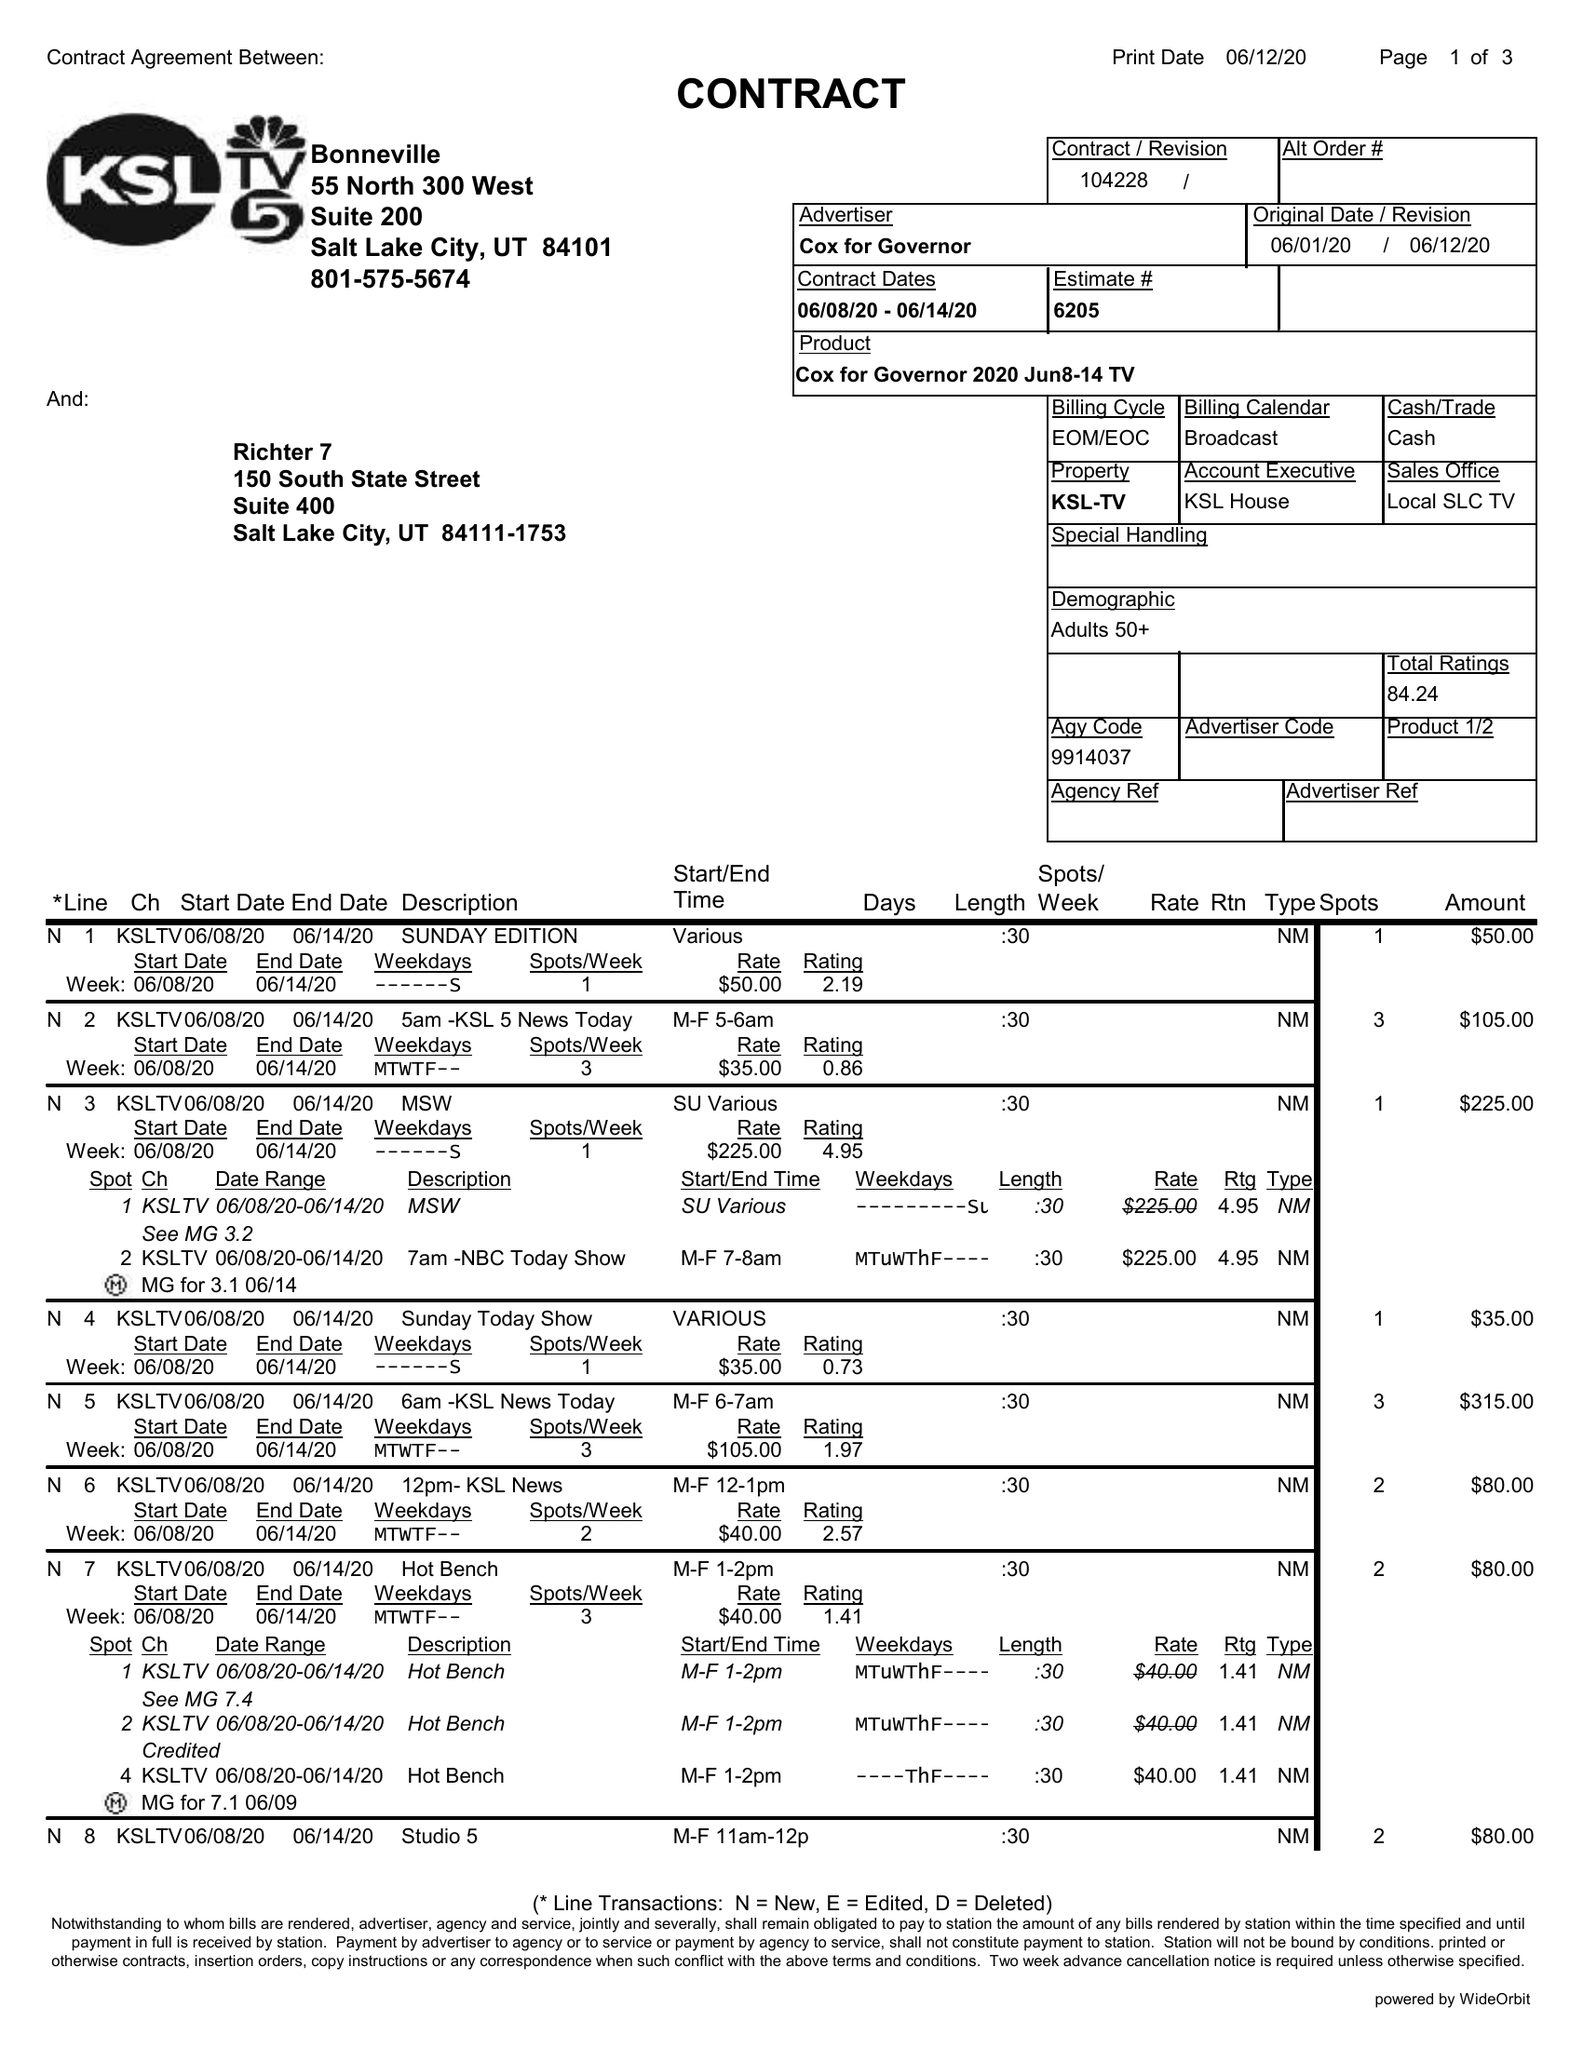What is the value for the advertiser?
Answer the question using a single word or phrase. COX FOR GOVERNOR 